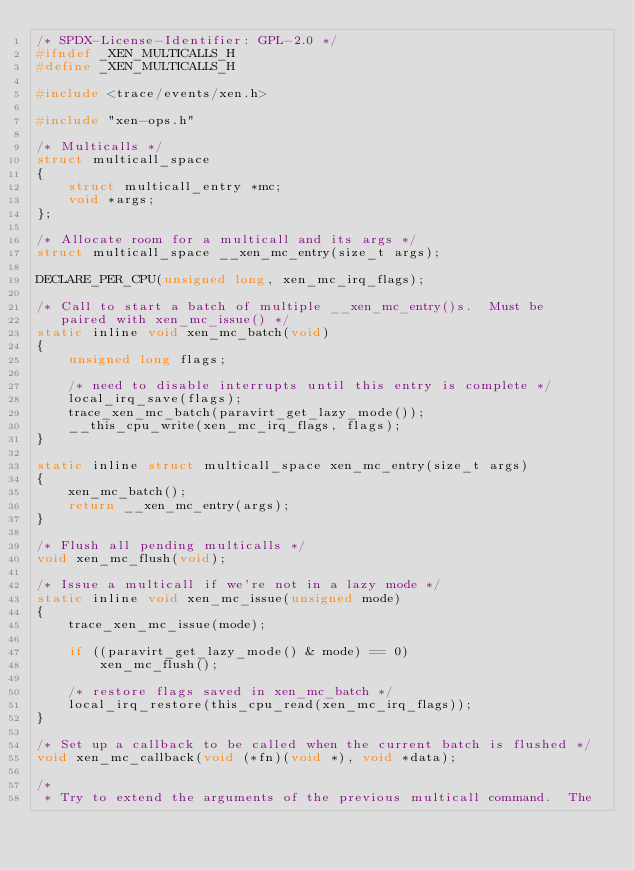<code> <loc_0><loc_0><loc_500><loc_500><_C_>/* SPDX-License-Identifier: GPL-2.0 */
#ifndef _XEN_MULTICALLS_H
#define _XEN_MULTICALLS_H

#include <trace/events/xen.h>

#include "xen-ops.h"

/* Multicalls */
struct multicall_space
{
	struct multicall_entry *mc;
	void *args;
};

/* Allocate room for a multicall and its args */
struct multicall_space __xen_mc_entry(size_t args);

DECLARE_PER_CPU(unsigned long, xen_mc_irq_flags);

/* Call to start a batch of multiple __xen_mc_entry()s.  Must be
   paired with xen_mc_issue() */
static inline void xen_mc_batch(void)
{
	unsigned long flags;

	/* need to disable interrupts until this entry is complete */
	local_irq_save(flags);
	trace_xen_mc_batch(paravirt_get_lazy_mode());
	__this_cpu_write(xen_mc_irq_flags, flags);
}

static inline struct multicall_space xen_mc_entry(size_t args)
{
	xen_mc_batch();
	return __xen_mc_entry(args);
}

/* Flush all pending multicalls */
void xen_mc_flush(void);

/* Issue a multicall if we're not in a lazy mode */
static inline void xen_mc_issue(unsigned mode)
{
	trace_xen_mc_issue(mode);

	if ((paravirt_get_lazy_mode() & mode) == 0)
		xen_mc_flush();

	/* restore flags saved in xen_mc_batch */
	local_irq_restore(this_cpu_read(xen_mc_irq_flags));
}

/* Set up a callback to be called when the current batch is flushed */
void xen_mc_callback(void (*fn)(void *), void *data);

/*
 * Try to extend the arguments of the previous multicall command.  The</code> 